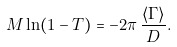Convert formula to latex. <formula><loc_0><loc_0><loc_500><loc_500>M \ln ( 1 - T ) = - 2 \pi \, \frac { \langle \Gamma \rangle } { D } .</formula> 